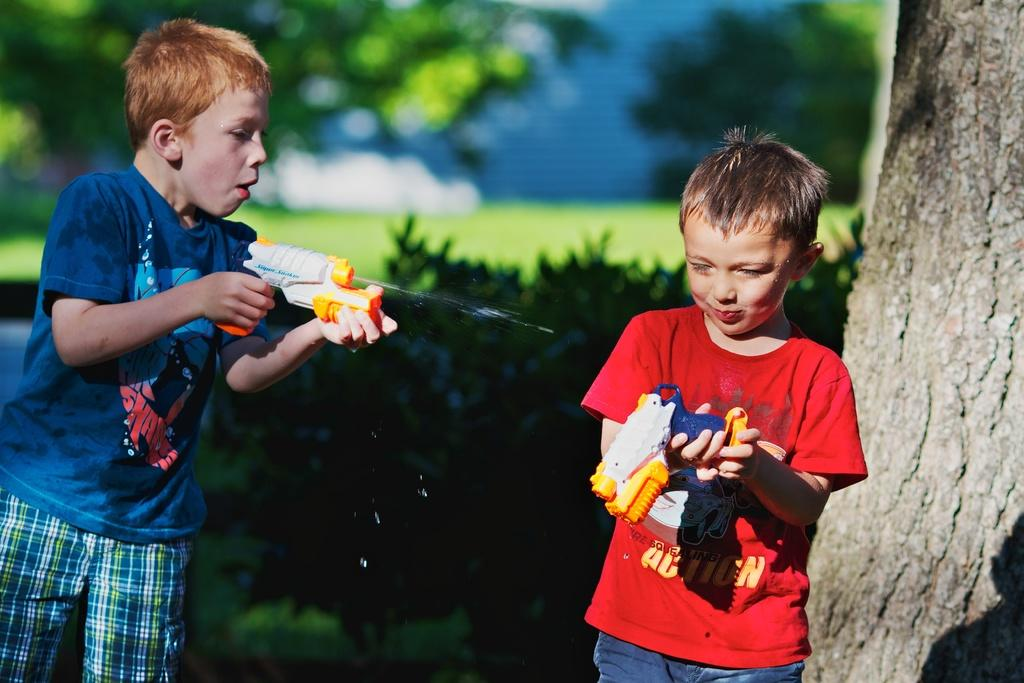What are the boys in the image doing? The boys are standing on the ground and holding toys in their hands. What can be seen in the background of the image? There are trees and bushes in the background of the image. What type of van is parked near the boys in the image? There is no van present in the image; it only features boys standing on the ground and holding toys, with trees and bushes in the background. 